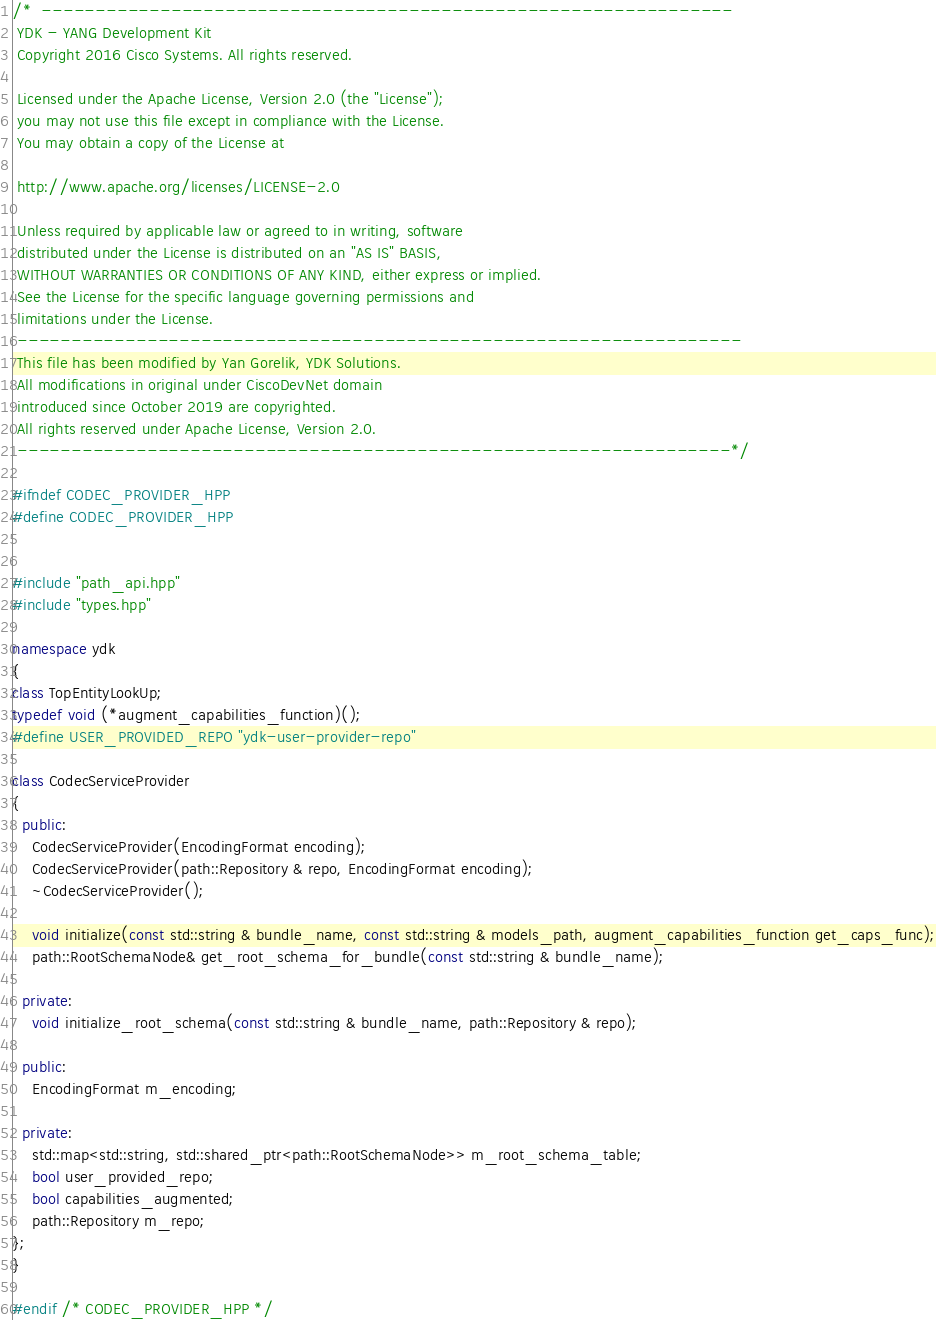Convert code to text. <code><loc_0><loc_0><loc_500><loc_500><_C++_>/*  ----------------------------------------------------------------
 YDK - YANG Development Kit
 Copyright 2016 Cisco Systems. All rights reserved.

 Licensed under the Apache License, Version 2.0 (the "License");
 you may not use this file except in compliance with the License.
 You may obtain a copy of the License at

 http://www.apache.org/licenses/LICENSE-2.0

 Unless required by applicable law or agreed to in writing, software
 distributed under the License is distributed on an "AS IS" BASIS,
 WITHOUT WARRANTIES OR CONDITIONS OF ANY KIND, either express or implied.
 See the License for the specific language governing permissions and
 limitations under the License.
 -------------------------------------------------------------------
 This file has been modified by Yan Gorelik, YDK Solutions.
 All modifications in original under CiscoDevNet domain
 introduced since October 2019 are copyrighted.
 All rights reserved under Apache License, Version 2.0.
 ------------------------------------------------------------------*/

#ifndef CODEC_PROVIDER_HPP
#define CODEC_PROVIDER_HPP


#include "path_api.hpp"
#include "types.hpp"

namespace ydk
{
class TopEntityLookUp;
typedef void (*augment_capabilities_function)();
#define USER_PROVIDED_REPO "ydk-user-provider-repo"

class CodecServiceProvider
{
  public:
    CodecServiceProvider(EncodingFormat encoding);
    CodecServiceProvider(path::Repository & repo, EncodingFormat encoding);
    ~CodecServiceProvider();

    void initialize(const std::string & bundle_name, const std::string & models_path, augment_capabilities_function get_caps_func);
    path::RootSchemaNode& get_root_schema_for_bundle(const std::string & bundle_name);

  private:
    void initialize_root_schema(const std::string & bundle_name, path::Repository & repo);

  public:
    EncodingFormat m_encoding;

  private:
    std::map<std::string, std::shared_ptr<path::RootSchemaNode>> m_root_schema_table;
    bool user_provided_repo;
    bool capabilities_augmented;
    path::Repository m_repo;
};
}

#endif /* CODEC_PROVIDER_HPP */
</code> 